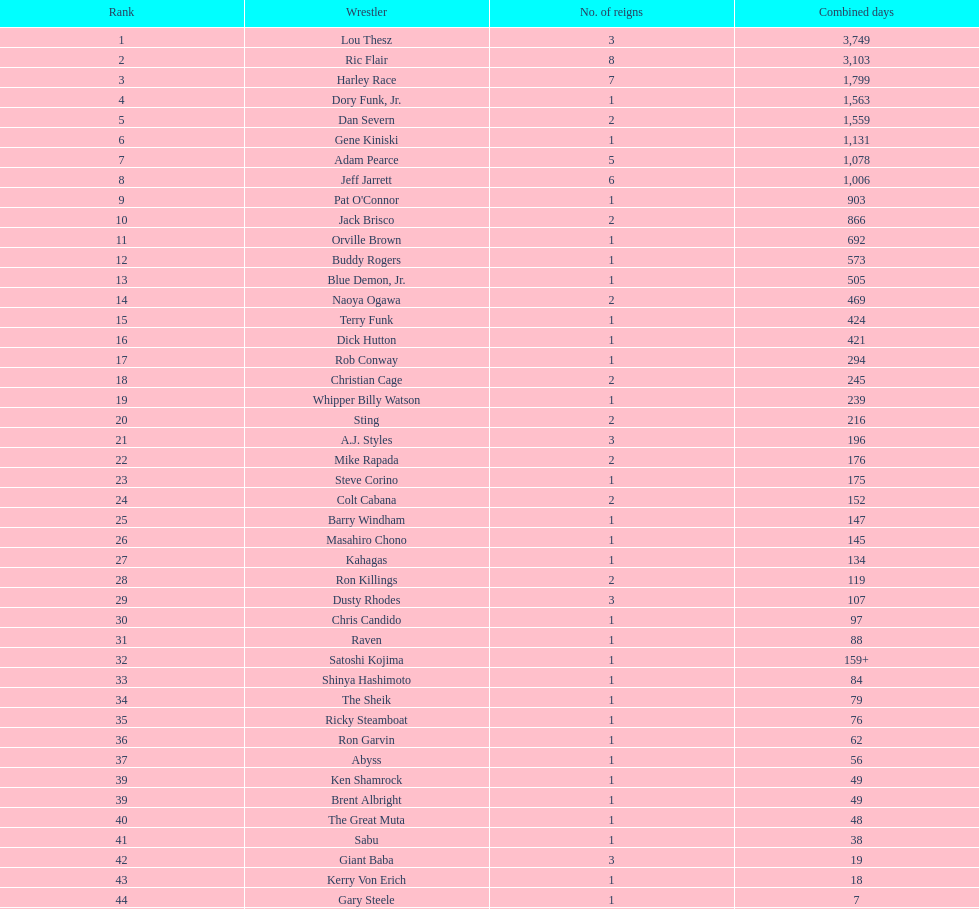How many days did orville brown hold the nwa world heavyweight championship title? 692 days. 